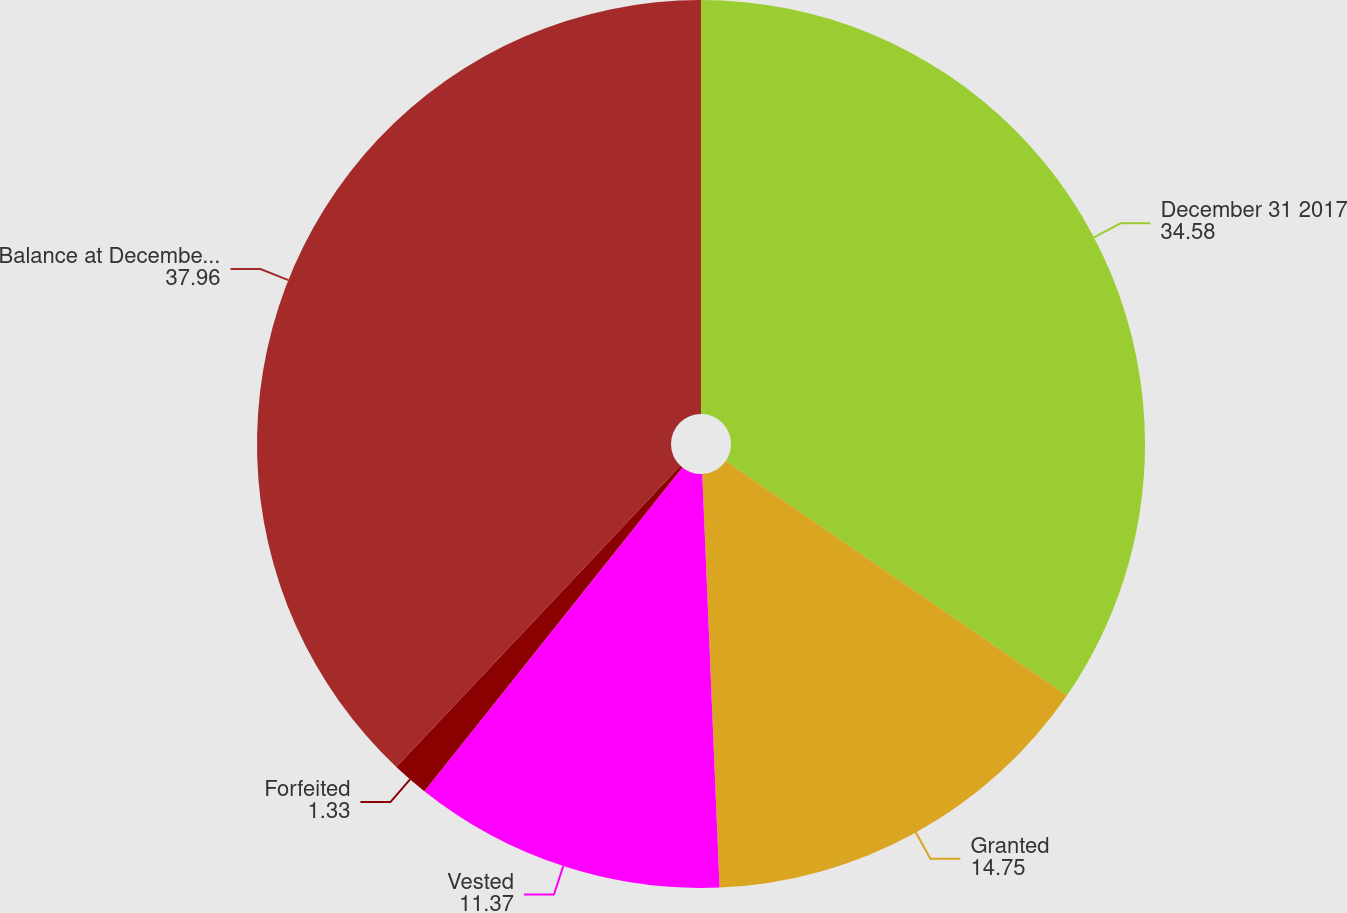Convert chart. <chart><loc_0><loc_0><loc_500><loc_500><pie_chart><fcel>December 31 2017<fcel>Granted<fcel>Vested<fcel>Forfeited<fcel>Balance at December 31 2018<nl><fcel>34.58%<fcel>14.75%<fcel>11.37%<fcel>1.33%<fcel>37.96%<nl></chart> 